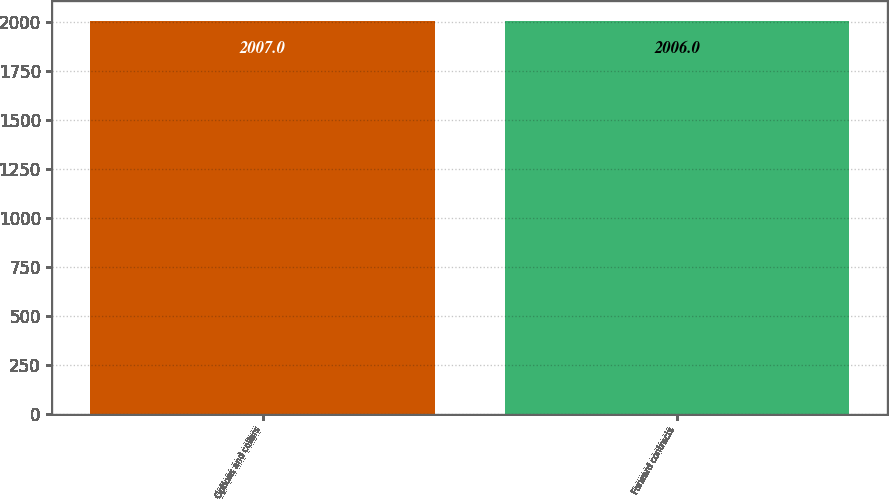Convert chart to OTSL. <chart><loc_0><loc_0><loc_500><loc_500><bar_chart><fcel>Options and collars<fcel>Forward contracts<nl><fcel>2007<fcel>2006<nl></chart> 